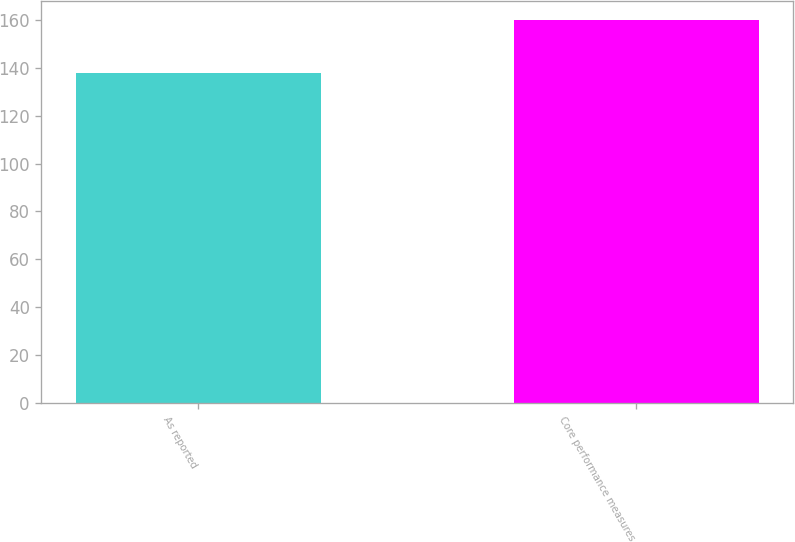<chart> <loc_0><loc_0><loc_500><loc_500><bar_chart><fcel>As reported<fcel>Core performance measures<nl><fcel>138<fcel>160<nl></chart> 